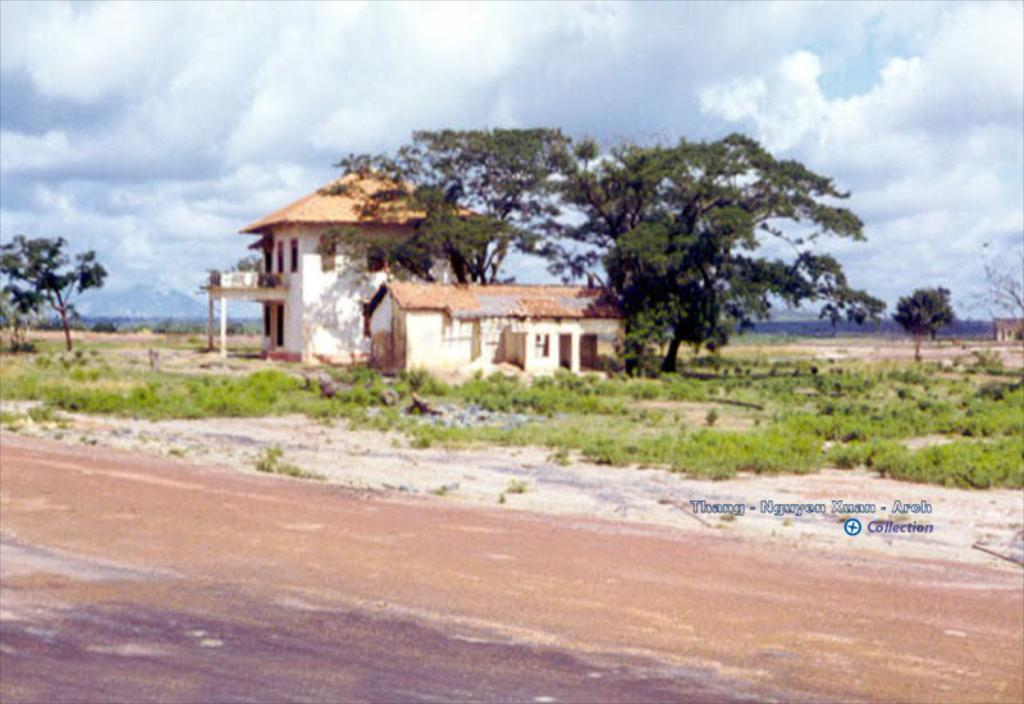What can be seen at the bottom of the image? The ground is visible at the bottom of the image. What is visible in the background of the image? There are plants, trees, two houses, mountains, and clouds in the sky in the background of the image. Can you describe the houses in the background? The houses in the background have windows visible on them. How many houses are there in the image? There are two houses in the background and one house on the right side of the image. What type of cream can be seen dripping from the plants in the image? There is no cream dripping from the plants in the image; the plants are not associated with any cream. What type of plant is shown walking across the ground in the image? There is no plant shown walking across the ground in the image; plants do not have the ability to walk. 